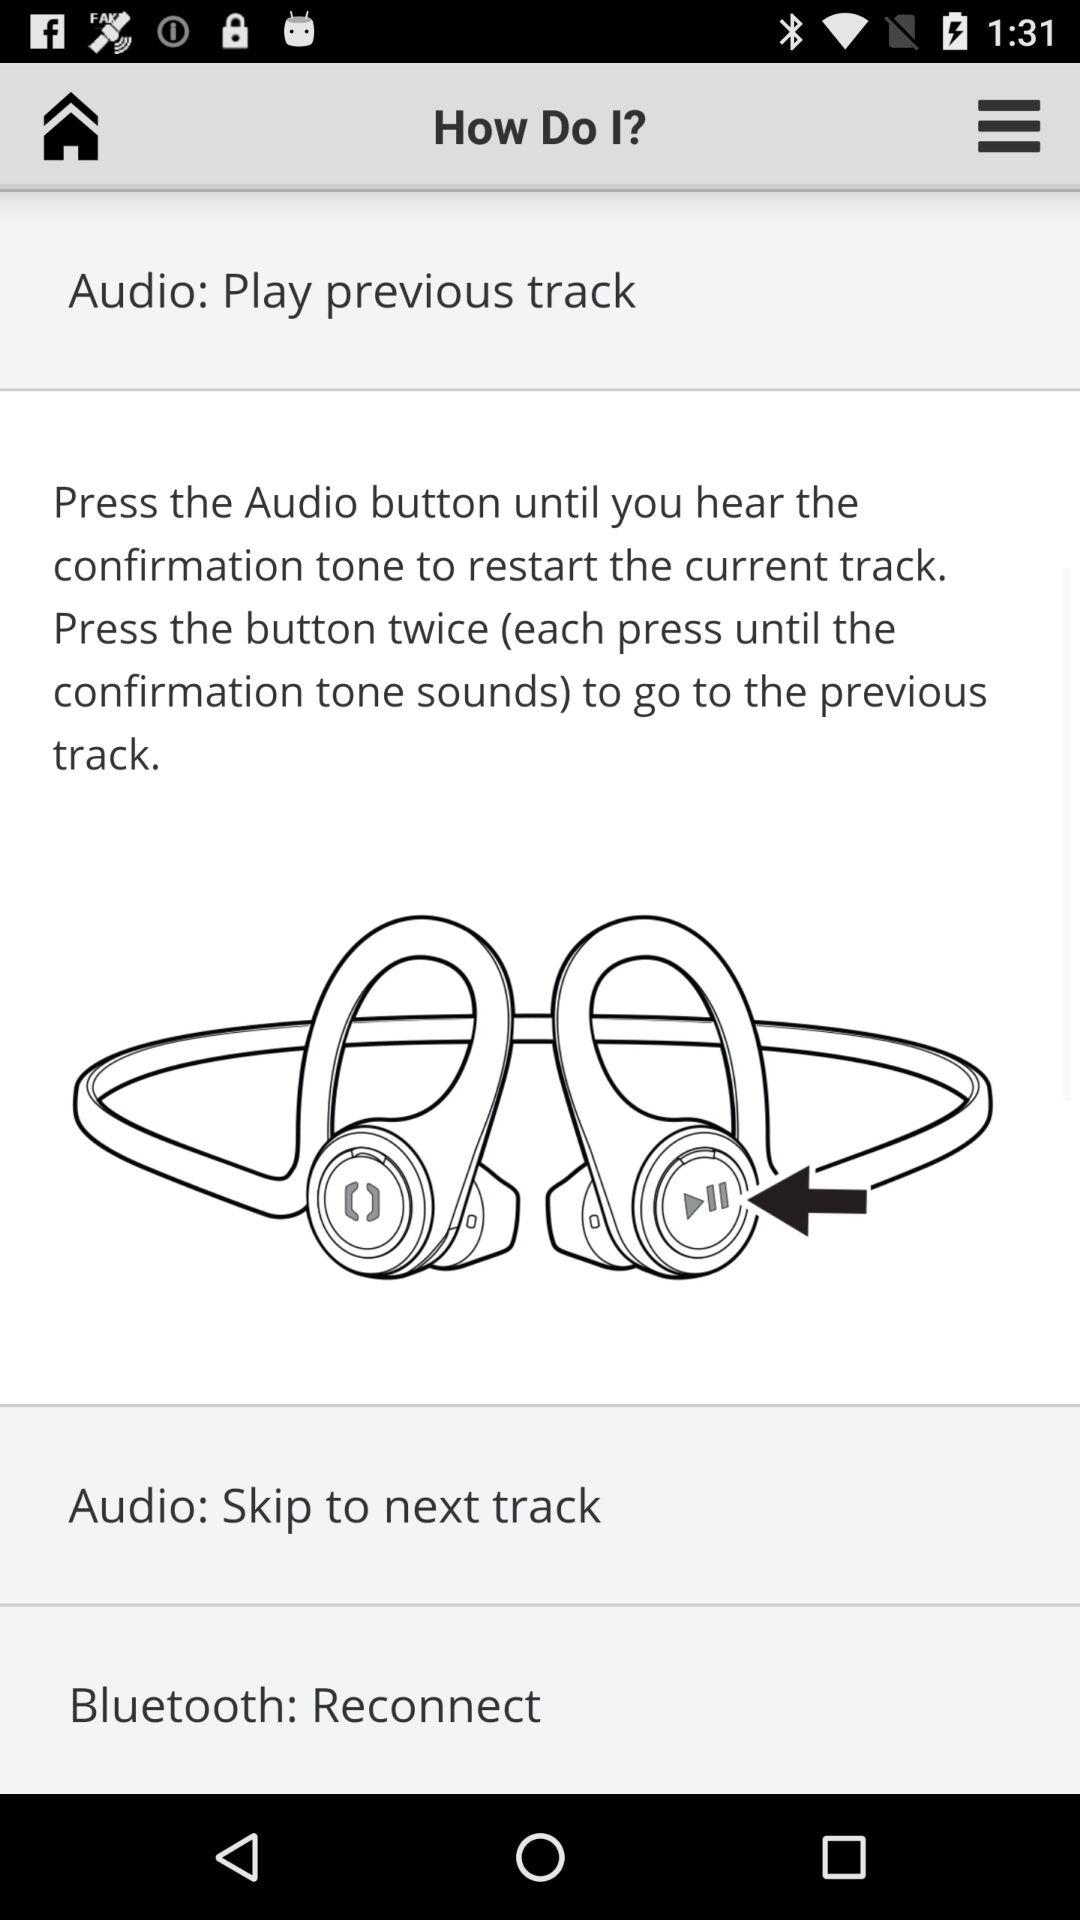How many more tracks can I skip than go back?
Answer the question using a single word or phrase. 1 